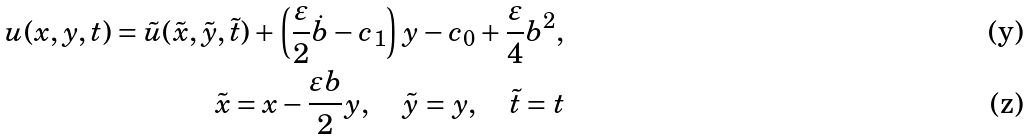<formula> <loc_0><loc_0><loc_500><loc_500>u ( x , y , t ) = \tilde { u } ( \tilde { x } , \tilde { y } , \tilde { t } ) + \left ( \frac { \varepsilon } { 2 } \dot { b } - c _ { 1 } \right ) y - c _ { 0 } + \frac { \varepsilon } { 4 } b ^ { 2 } , \\ \tilde { x } = x - \frac { \varepsilon b } { 2 } y , \quad \tilde { y } = y , \quad \tilde { t } = t</formula> 